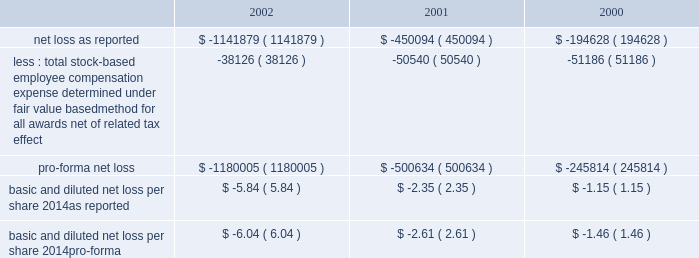American tower corporation and subsidiaries notes to consolidated financial statements 2014 ( continued ) the table illustrates the effect on net loss and net loss per share if the company had applied the fair value recognition provisions of sfas no .
123 to stock-based compensation .
The estimated fair value of each option is calculated using the black-scholes option-pricing model ( in thousands , except per share amounts ) : .
Fair value of financial instruments 2014as of december 31 , 2002 , the carrying amounts of the company 2019s 5.0% ( 5.0 % ) convertible notes , the 2.25% ( 2.25 % ) convertible notes , the 6.25% ( 6.25 % ) convertible notes and the senior notes were approximately $ 450.0 million , $ 210.9 million , $ 212.7 million and $ 1.0 billion , respectively , and the fair values of such notes were $ 291.4 million , $ 187.2 million , $ 144.4 million and $ 780.0 million , respectively .
As of december 31 , 2001 , the carrying amount of the company 2019s 5.0% ( 5.0 % ) convertible notes , the 2.25% ( 2.25 % ) convertible notes , the 6.25% ( 6.25 % ) convertible notes and the senior notes were approximately $ 450.0 million , $ 204.1 million , $ 212.8 million and $ 1.0 billion , respectively , and the fair values of such notes were $ 268.3 million , $ 173.1 million , $ 158.2 million and $ 805.0 million , respectively .
Fair values were determined based on quoted market prices .
The carrying values of all other financial instruments reasonably approximate the related fair values as of december 31 , 2002 and 2001 .
Retirement plan 2014the company has a 401 ( k ) plan covering substantially all employees who meet certain age and employment requirements .
Under the plan , the company matches 35% ( 35 % ) of participants 2019 contributions up to a maximum 5% ( 5 % ) of a participant 2019s compensation .
The company contributed approximately $ 979000 , $ 1540000 and $ 1593000 to the plan for the years ended december 31 , 2002 , 2001 and 2000 , respectively .
Recent accounting pronouncements 2014in june 2001 , the fasb issued sfas no .
143 , 201caccounting for asset retirement obligations . 201d this statement establishes accounting standards for the recognition and measurement of liabilities associated with the retirement of tangible long-lived assets and the related asset retirement costs .
The requirements of sfas no .
143 are effective for the company as of january 1 , 2003 .
The company will adopt this statement in the first quarter of 2003 and does not expect the impact of adopting this statement to have a material impact on its consolidated financial position or results of operations .
In august 2001 , the fasb issued sfas no .
144 , 201caccounting for the impairment or disposal of long-lived assets . 201d sfas no .
144 supersedes sfas no .
121 , 201caccounting for the impairment of long-lived assets and for long-lived assets to be disposed of , 201d but retains many of its fundamental provisions .
Sfas no .
144 also clarifies certain measurement and classification issues from sfas no .
121 .
In addition , sfas no .
144 supersedes the accounting and reporting provisions for the disposal of a business segment as found in apb no .
30 , 201creporting the results of operations 2014reporting the effects of disposal of a segment of a business and extraordinary , unusual and infrequently occurring events and transactions 201d .
However , sfas no .
144 retains the requirement in apb no .
30 to separately report discontinued operations , and broadens the scope of such requirement to include more types of disposal transactions .
The scope of sfas no .
144 excludes goodwill and other intangible assets that are not to be amortized , as the accounting for such items is prescribed by sfas no .
142 .
The company implemented sfas no .
144 on january 1 , 2002 .
Accordingly , all relevant impairment assessments and decisions concerning discontinued operations have been made under this standard in 2002. .
What was the average company matching contribution to the 401k retirement contribution for the employees from 2000 to 2002? 
Computations: (((979000 + 1540000) + 1593000) / 3)
Answer: 1370666.66667. 